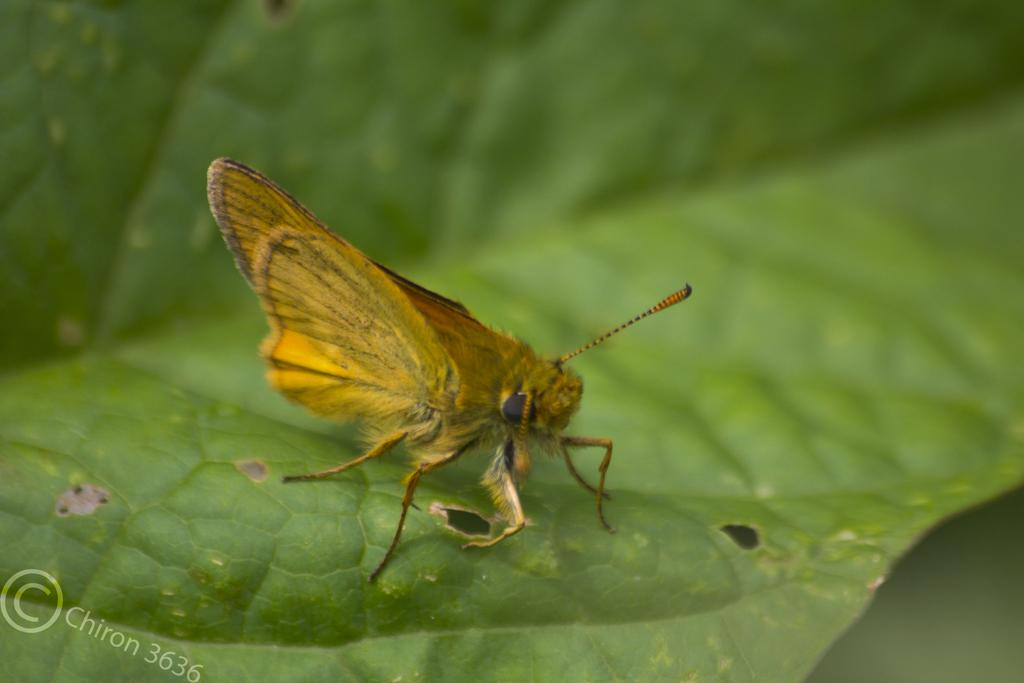What is on the leaf in the image? There is an insect on a leaf in the image. What else can be seen in the image besides the insect and leaf? There is a watermark, some text, and numbers in the image. What type of treatment is the squirrel receiving in the image? There is no squirrel present in the image, so it is not possible to determine if any treatment is being administered. 